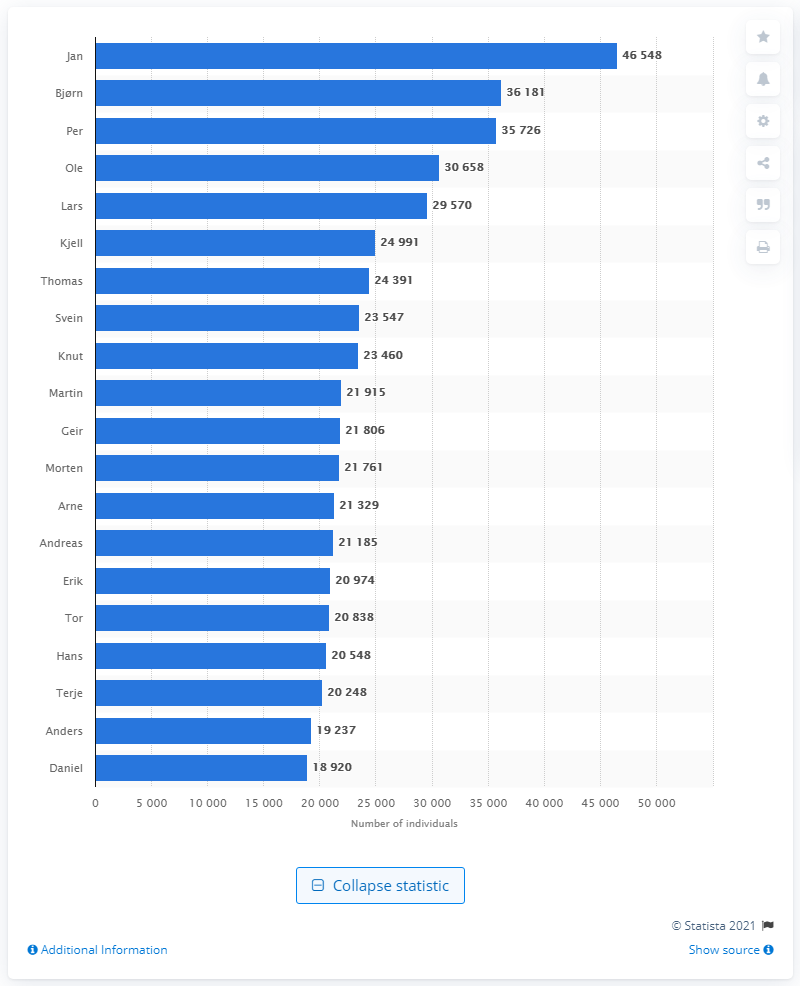Outline some significant characteristics in this image. The most common male name in Norway is Jan. 